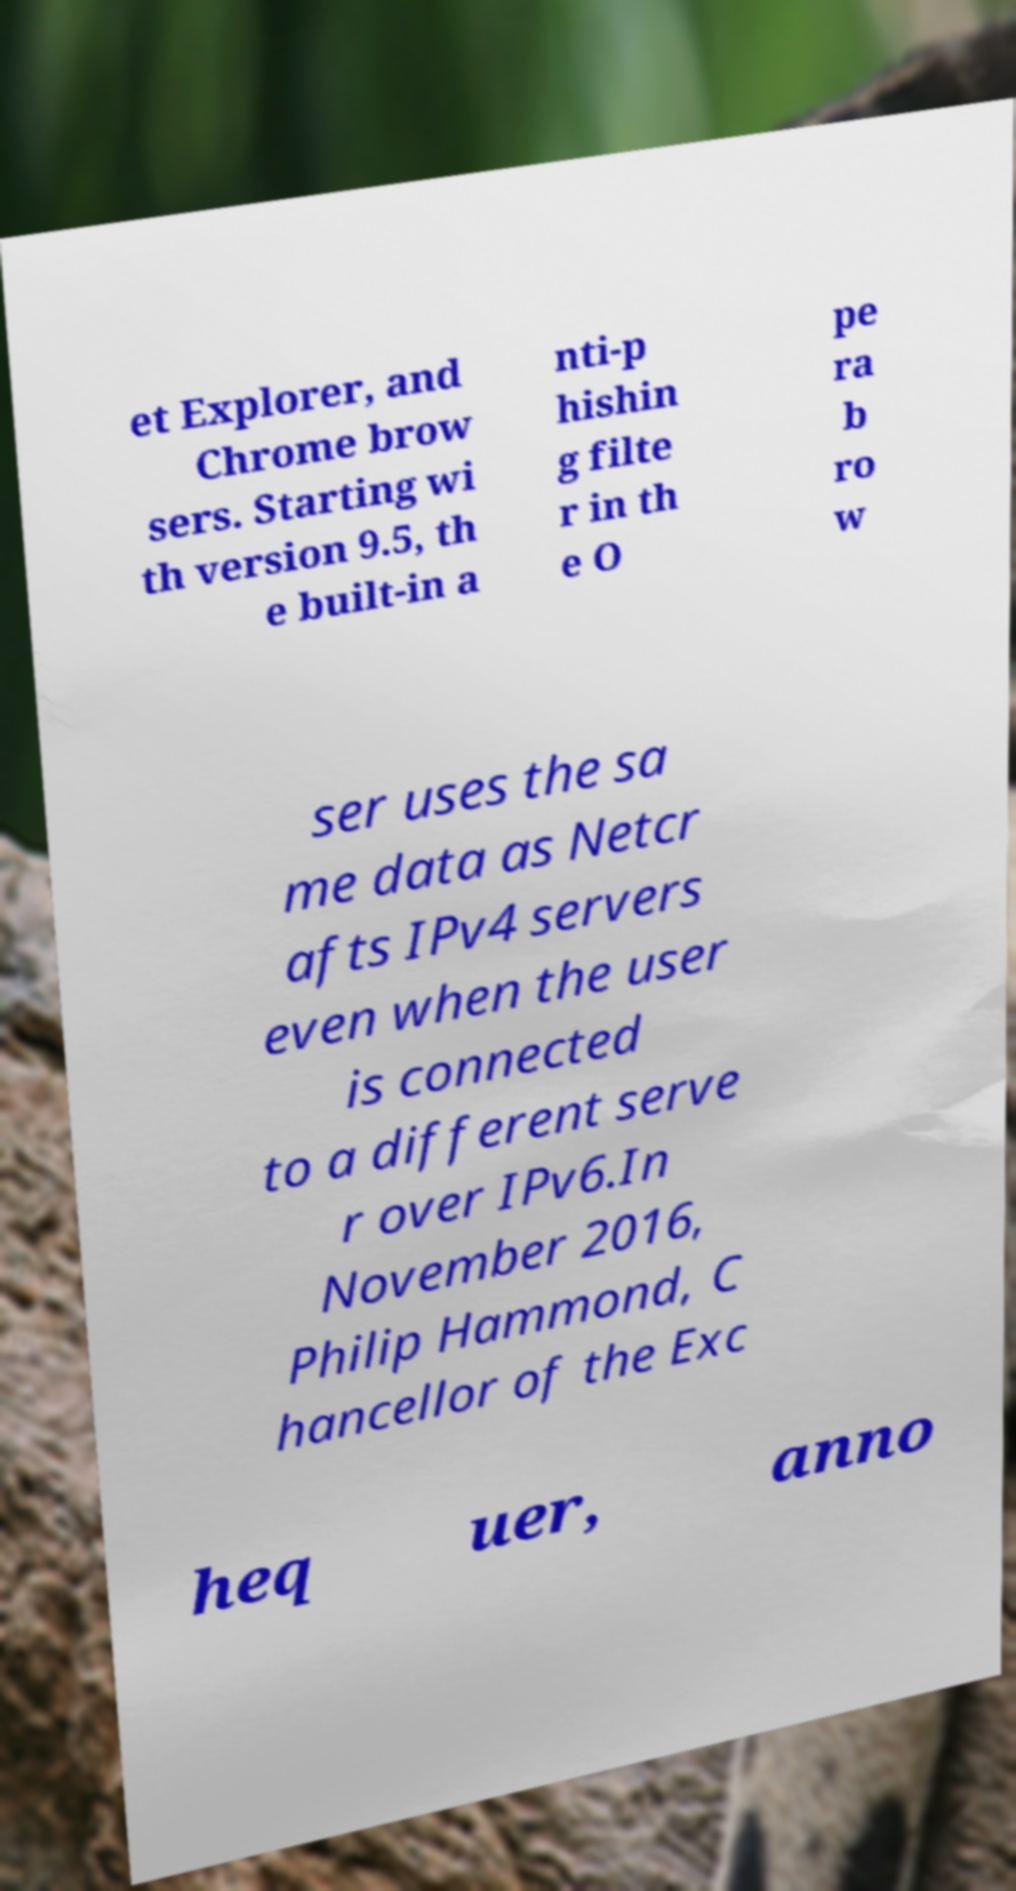Can you accurately transcribe the text from the provided image for me? et Explorer, and Chrome brow sers. Starting wi th version 9.5, th e built-in a nti-p hishin g filte r in th e O pe ra b ro w ser uses the sa me data as Netcr afts IPv4 servers even when the user is connected to a different serve r over IPv6.In November 2016, Philip Hammond, C hancellor of the Exc heq uer, anno 